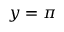<formula> <loc_0><loc_0><loc_500><loc_500>y = \pi</formula> 